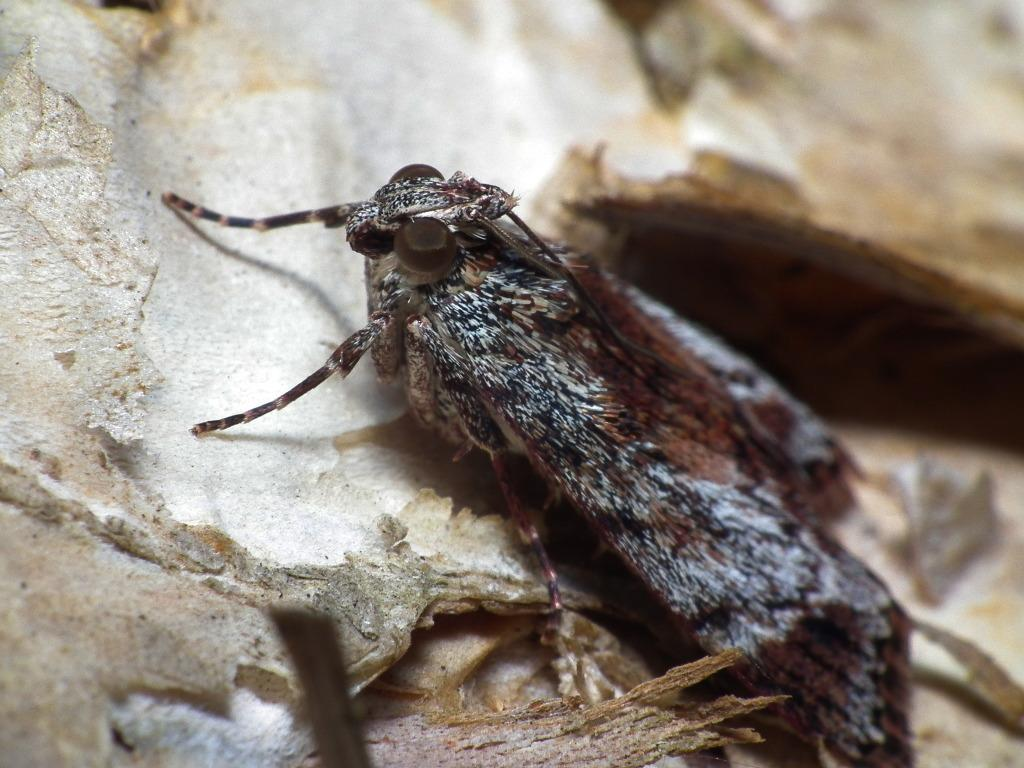What is located in the foreground of the image? There is an insect in the foreground of the image. What type of objects can be seen at the bottom of the image? There are wooden objects at the bottom of the image. What is visible on the left side of the image? There appears to be a wall on the left side of the image. How does the insect attempt to crack the wooden objects in the image? There is no indication in the image that the insect is attempting to crack the wooden objects. 